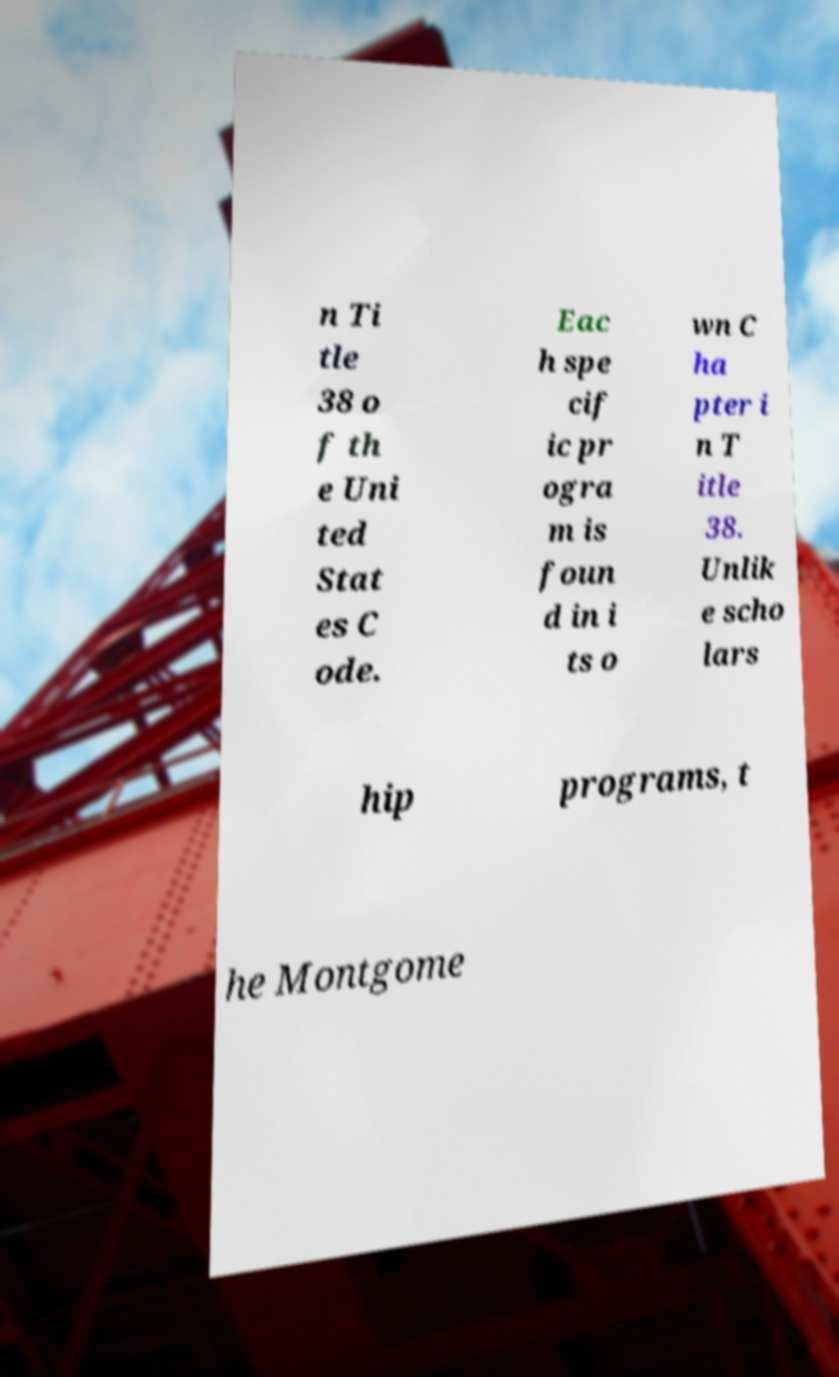What messages or text are displayed in this image? I need them in a readable, typed format. n Ti tle 38 o f th e Uni ted Stat es C ode. Eac h spe cif ic pr ogra m is foun d in i ts o wn C ha pter i n T itle 38. Unlik e scho lars hip programs, t he Montgome 